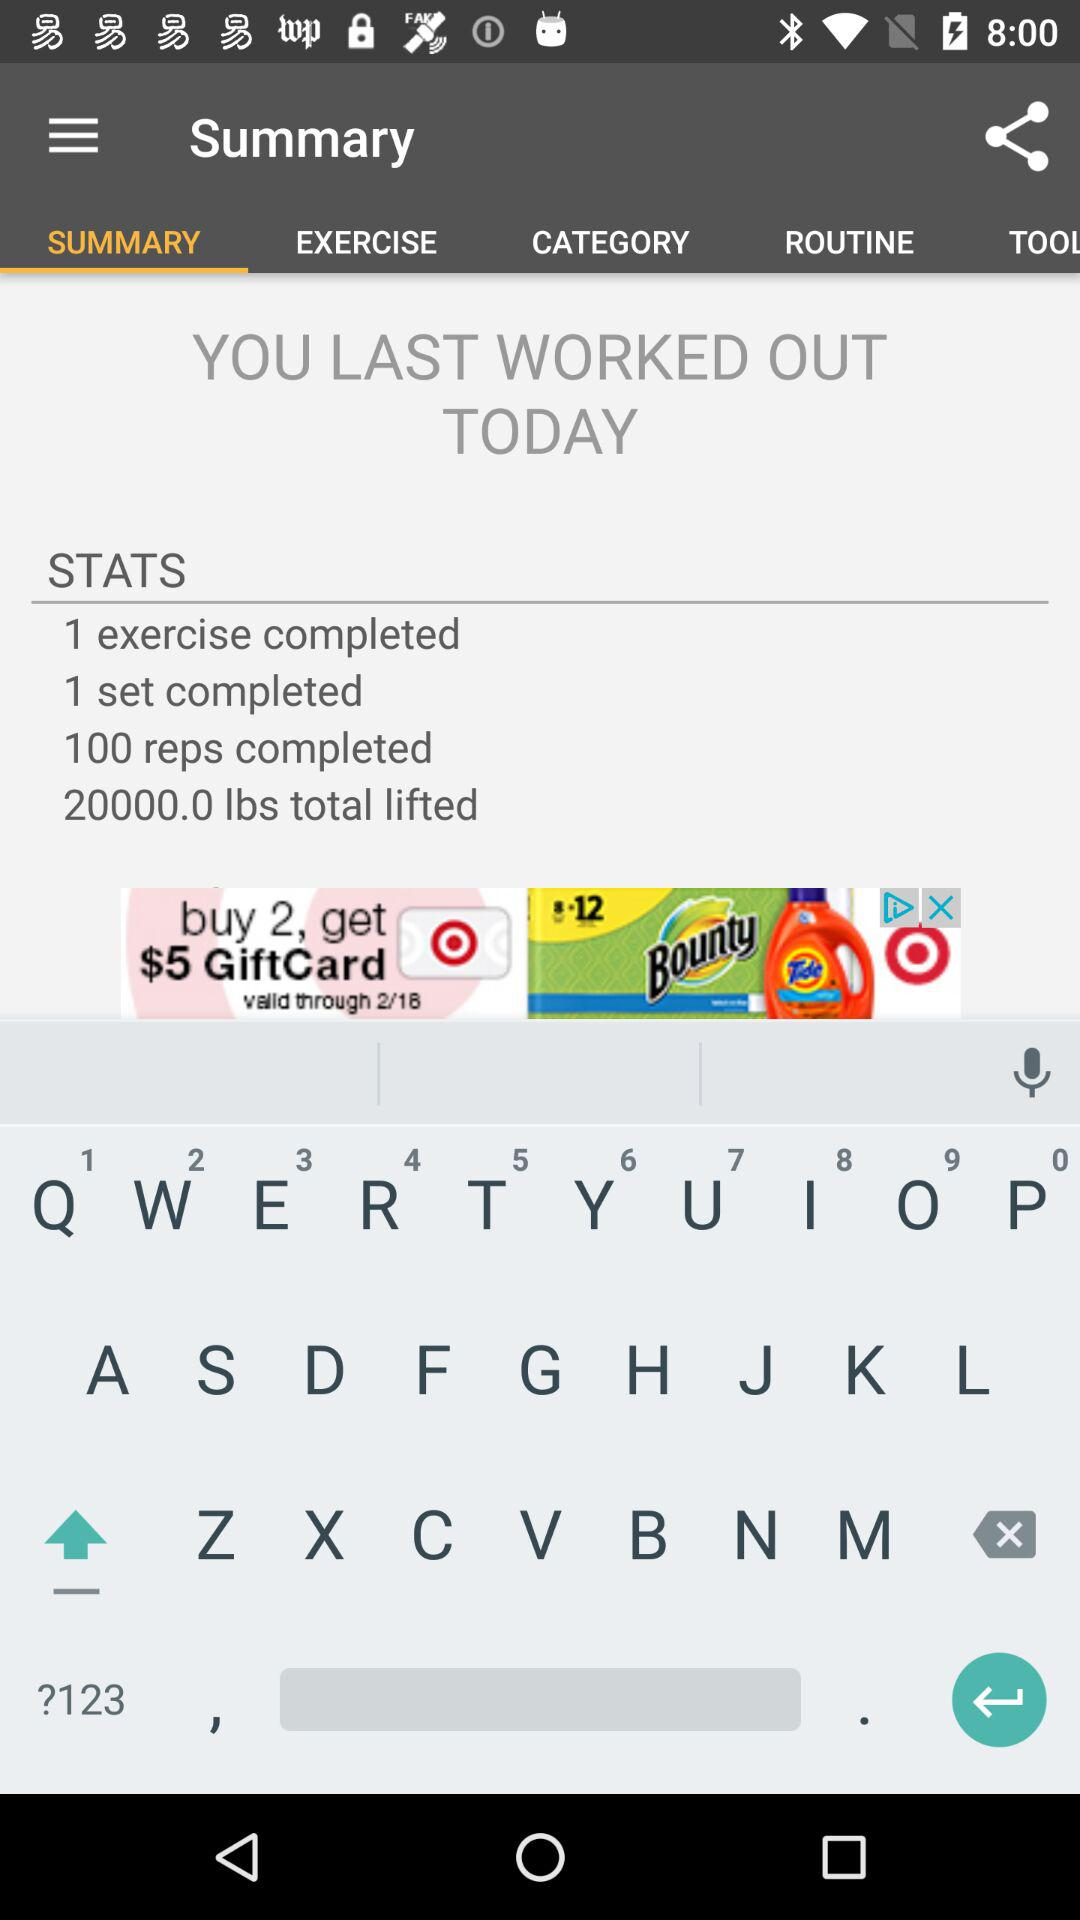How many reps did you complete? According to the workout summary displayed on the screen, you completed an impressive 100 reps in your last session today. 